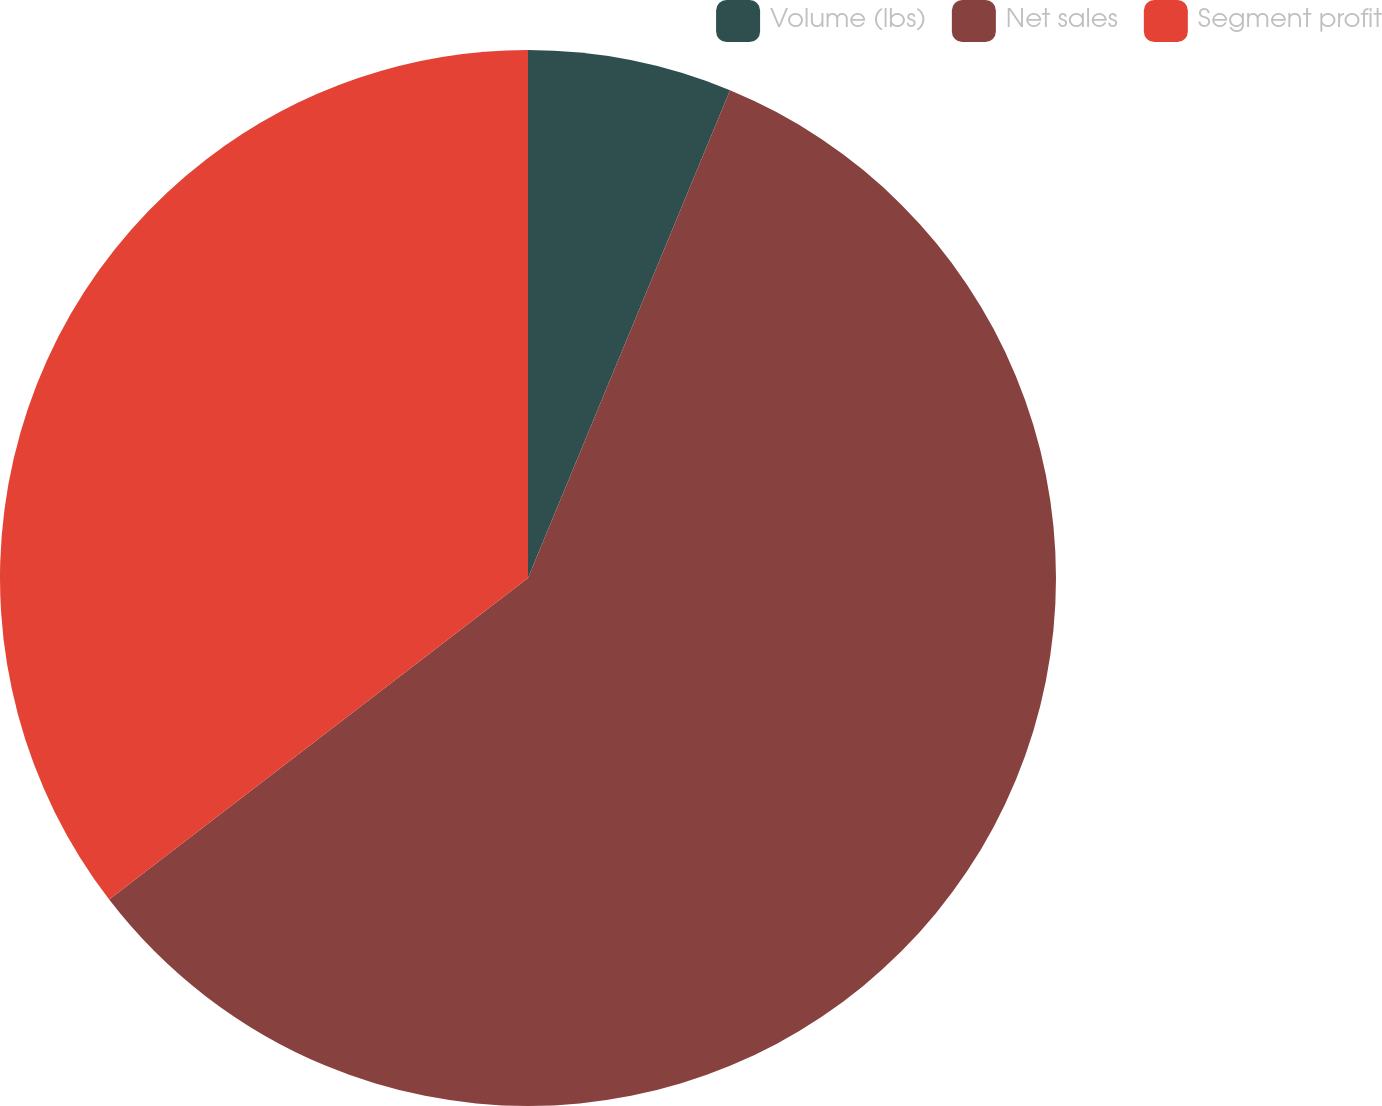Convert chart. <chart><loc_0><loc_0><loc_500><loc_500><pie_chart><fcel>Volume (lbs)<fcel>Net sales<fcel>Segment profit<nl><fcel>6.25%<fcel>58.33%<fcel>35.42%<nl></chart> 